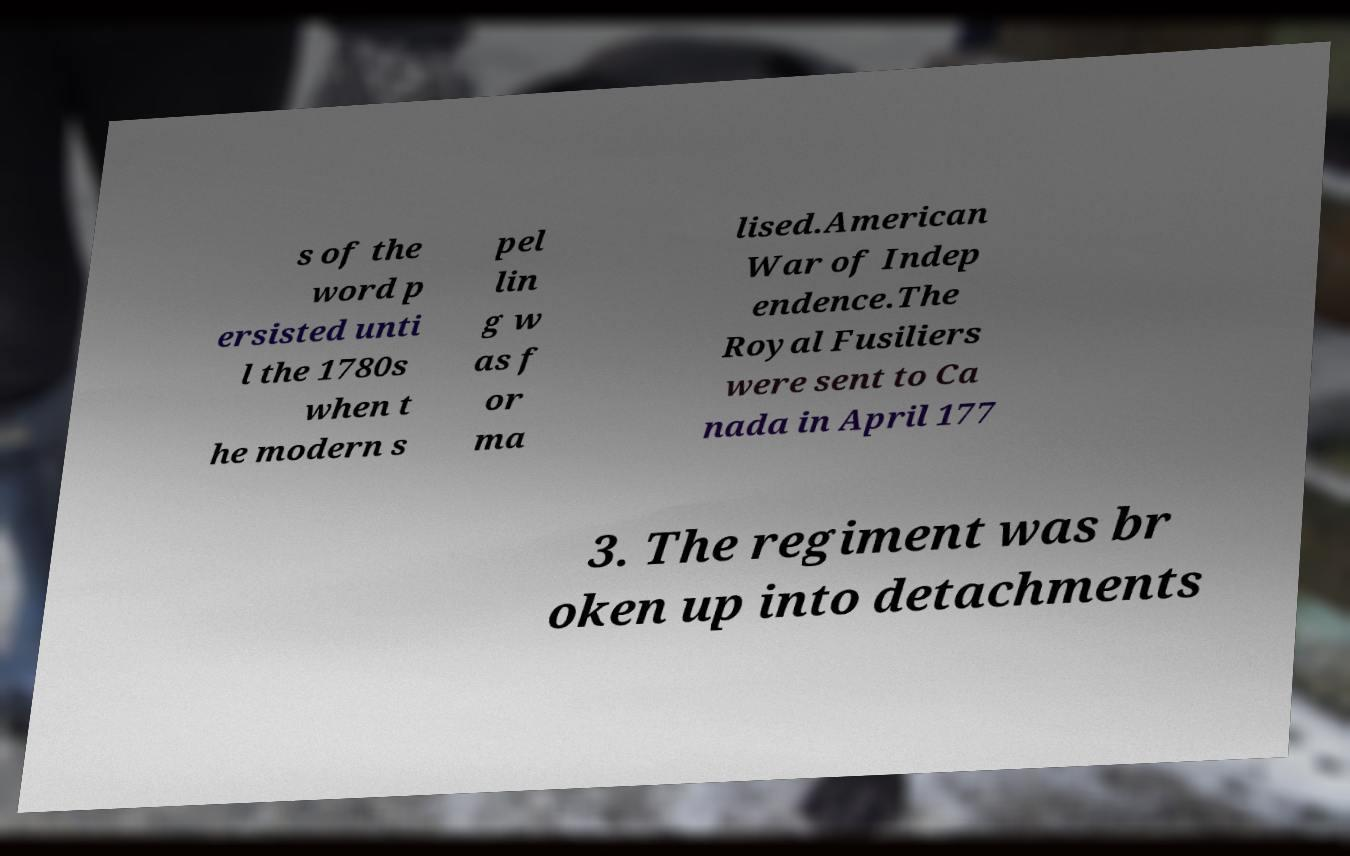Can you accurately transcribe the text from the provided image for me? s of the word p ersisted unti l the 1780s when t he modern s pel lin g w as f or ma lised.American War of Indep endence.The Royal Fusiliers were sent to Ca nada in April 177 3. The regiment was br oken up into detachments 